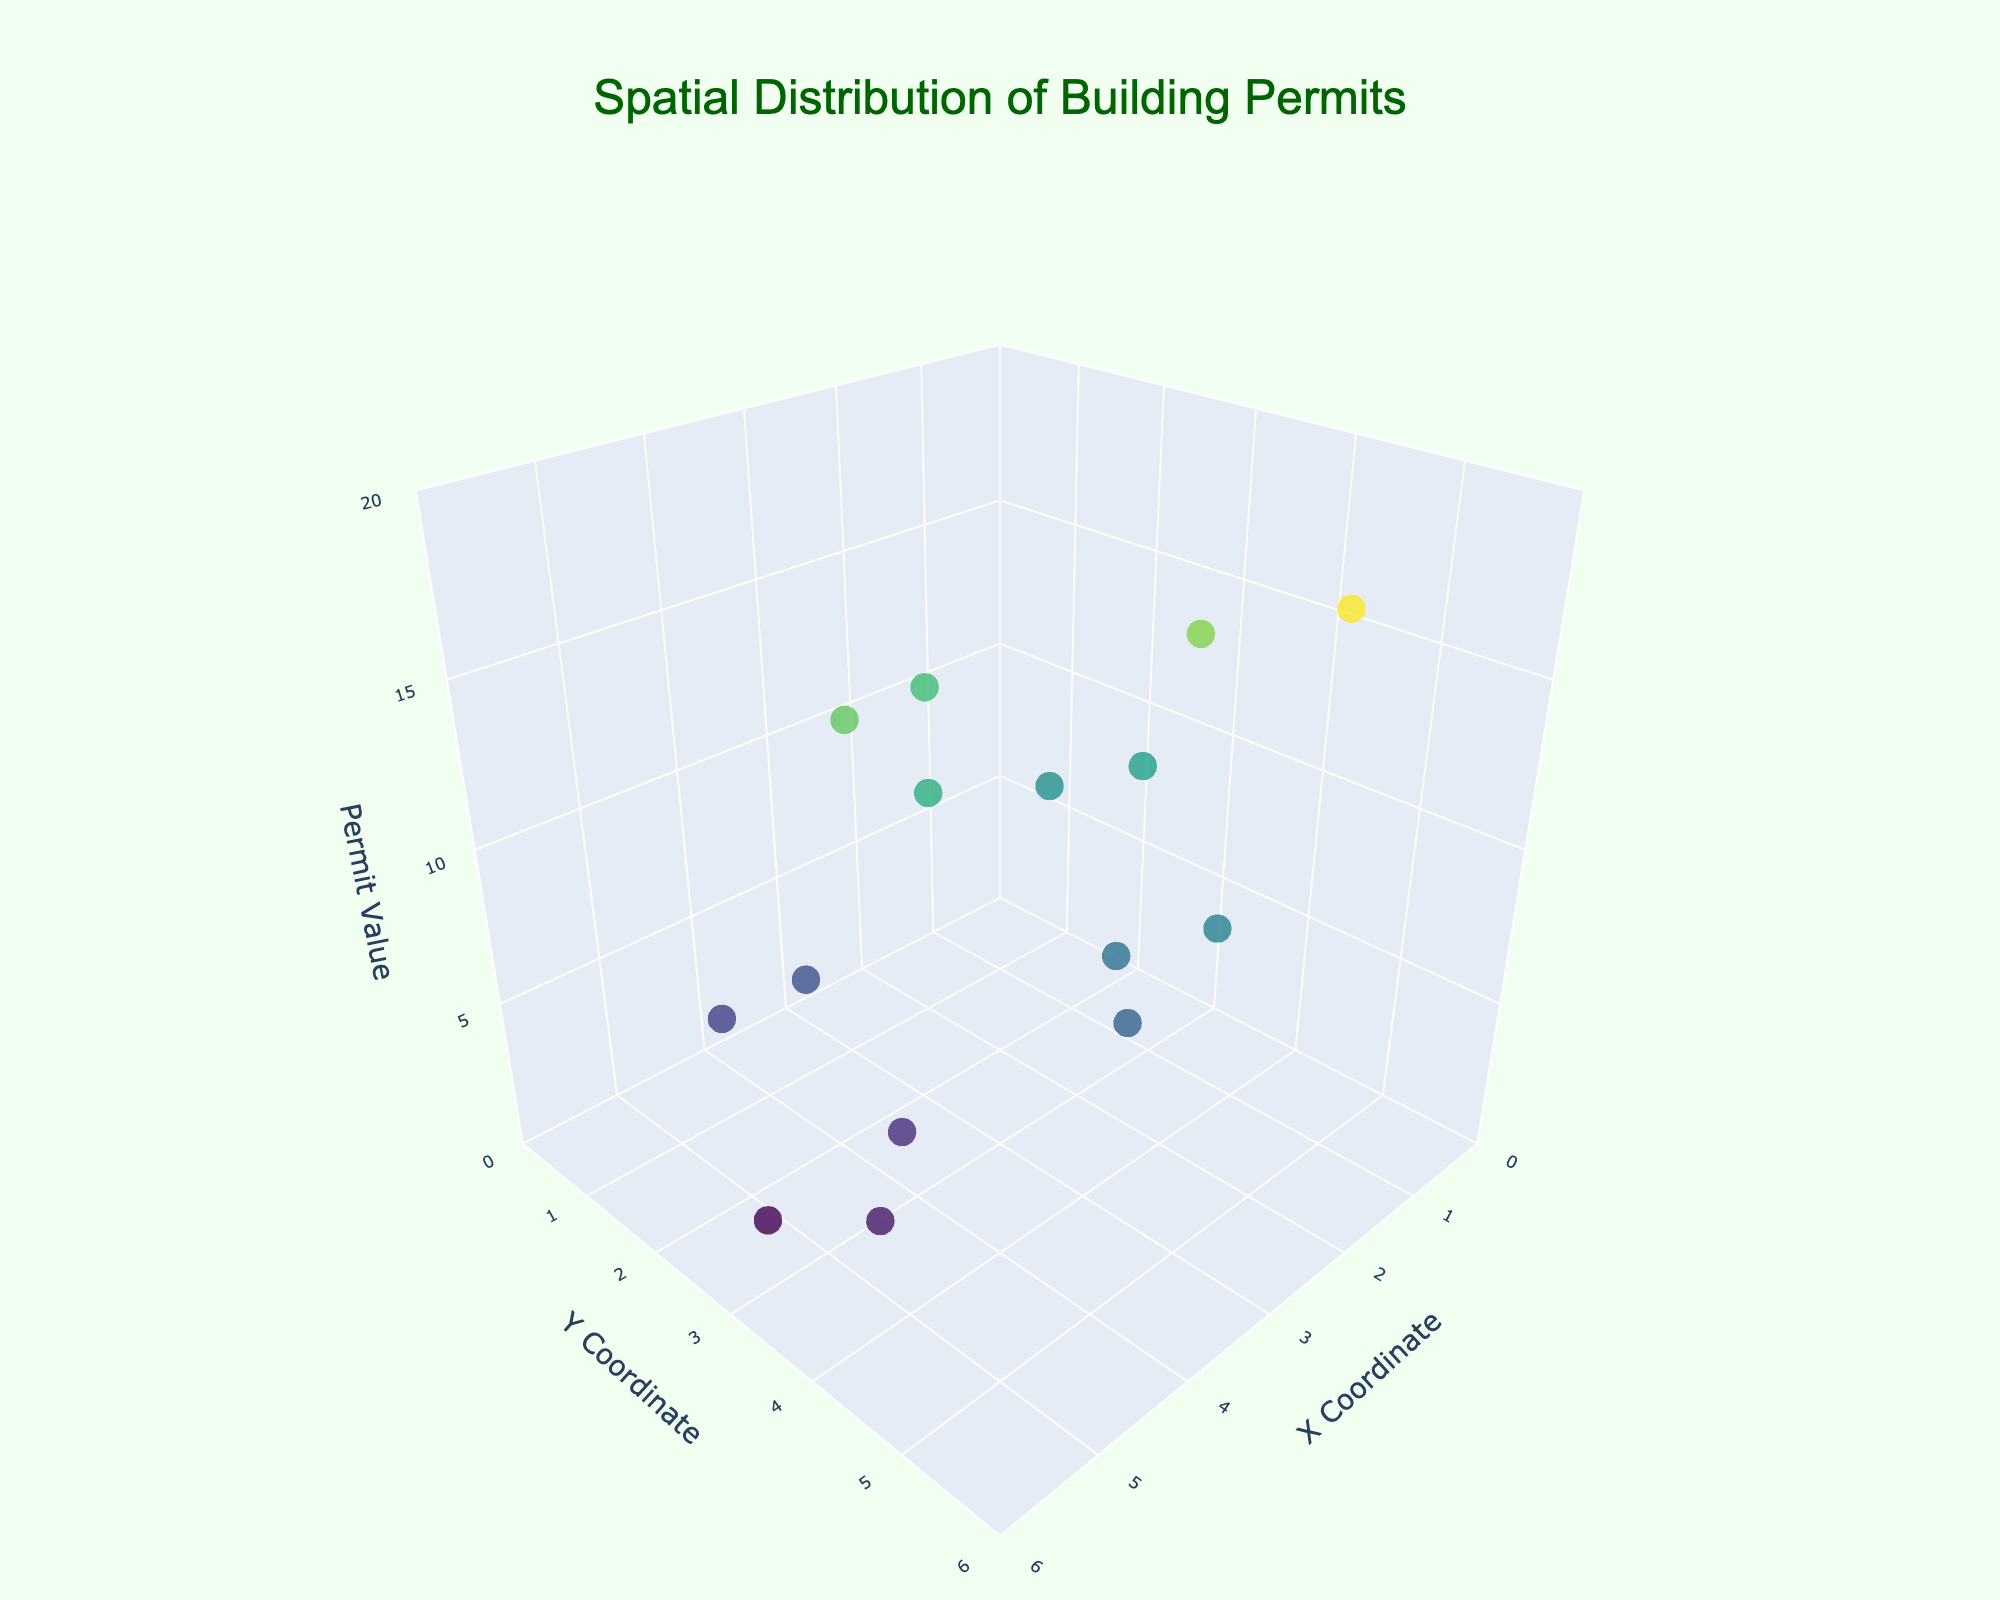What's the title of the 3D plot? The title is displayed at the top of the plot and is a clear indicator of what the chart is about.
Answer: Spatial Distribution of Building Permits What does the z-axis represent? The z-axis is labeled with "Permit Value," which indicates it represents the value associated with the building permits.
Answer: Permit Value Which protected area has the highest permit value? Hover over the data points or observe the z-axis values to find the highest point. The highest point (z_value of 18) corresponds to the Everglades National Park in the Wetland ecosystem.
Answer: Everglades National Park Which ecosystem type has the lowest building permit value? By hovering over the lowest data point (z_value of 2), we can see that it corresponds to the Sagebrush Steppe ecosystem in Craters of the Moon National Monument.
Answer: Sagebrush Steppe What is the average permit value of all the plotted points? Sum all the z_values (15 + 8 + 12 + 6 + 18 + 3 + 9 + 14 + 5 + 11 + 7 + 2 + 13 + 4 + 10) to get 137. There are 15 points, so the average is 137/15.
Answer: 9.13 In which coordinate range do most data points fall? By visually inspecting the plot, most data points seem clustered around the central region, particularly between the x_coord of 1.5-4.5 and y_coord of 2-5.
Answer: x: 1.5-4.5, y: 2-5 What is the typical range of permit values? By observing the range on the z-axis, the permit values are mostly between 2 and 18.
Answer: 2 to 18 Which data point is closest to the origin (0,0,0)? The closest data point will have the smallest combination of x, y, and z values. Here, the data point (1.2, 3.5, 15) for the Boreal Forest in Yellowstone National Park seems closest.
Answer: Yellowstone National Park How many ecosystems have permit values greater than 10? By counting the data points that have z_values greater than 10, we see that there are 6 such ecosystems: Boreal Forest, Alpine Tundra, Wetland, Mixed Deciduous Forest, Subalpine Forest, and Riparian Zone.
Answer: 6 Which protected areas have permit values less than 5? By identifying the data points with z_values less than 5, we find Joshua Tree National Park (3), Santa Monica Mountains National Recreation Area (5), Craters of the Moon National Monument (2), and Sequoia National Park (4).
Answer: Joshua Tree, Santa Monica Mountains, Craters of the Moon, Sequoia National Park 